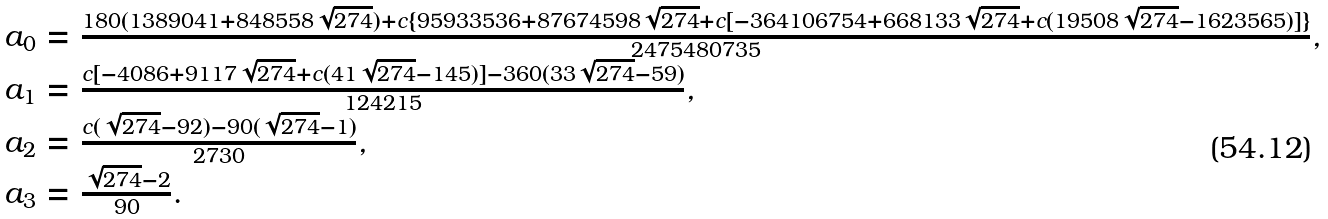Convert formula to latex. <formula><loc_0><loc_0><loc_500><loc_500>\begin{array} { l } a _ { 0 } = \frac { 1 8 0 ( 1 3 8 9 0 4 1 + 8 4 8 5 5 8 \sqrt { 2 7 4 } ) + c \{ 9 5 9 3 3 5 3 6 + 8 7 6 7 4 5 9 8 \sqrt { 2 7 4 } + c [ - 3 6 4 1 0 6 7 5 4 + 6 6 8 1 3 3 \sqrt { 2 7 4 } + c ( 1 9 5 0 8 \sqrt { 2 7 4 } - 1 6 2 3 5 6 5 ) ] \} } { 2 4 7 5 4 8 0 7 3 5 } , \\ a _ { 1 } = \frac { c [ - 4 0 8 6 + 9 1 1 7 \sqrt { 2 7 4 } + c ( 4 1 \sqrt { 2 7 4 } - 1 4 5 ) ] - 3 6 0 ( 3 3 \sqrt { 2 7 4 } - 5 9 ) } { 1 2 4 2 1 5 } , \\ a _ { 2 } = \frac { c ( \sqrt { 2 7 4 } - 9 2 ) - 9 0 ( \sqrt { 2 7 4 } - 1 ) } { 2 7 3 0 } , \\ a _ { 3 } = \frac { \sqrt { 2 7 4 } - 2 } { 9 0 } . \end{array}</formula> 